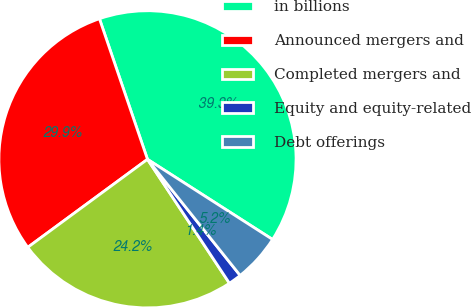Convert chart to OTSL. <chart><loc_0><loc_0><loc_500><loc_500><pie_chart><fcel>in billions<fcel>Announced mergers and<fcel>Completed mergers and<fcel>Equity and equity-related<fcel>Debt offerings<nl><fcel>39.31%<fcel>29.85%<fcel>24.21%<fcel>1.42%<fcel>5.21%<nl></chart> 